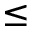Convert formula to latex. <formula><loc_0><loc_0><loc_500><loc_500>\leq</formula> 